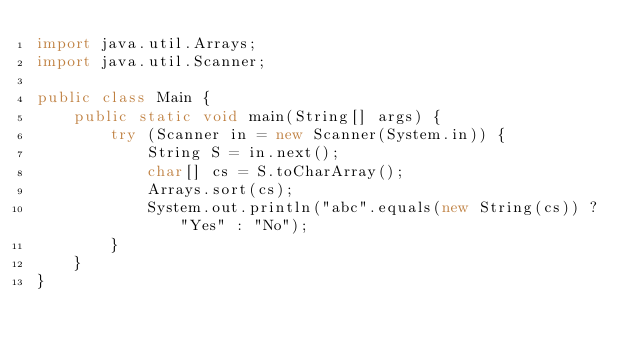<code> <loc_0><loc_0><loc_500><loc_500><_Java_>import java.util.Arrays;
import java.util.Scanner;

public class Main {
    public static void main(String[] args) {
        try (Scanner in = new Scanner(System.in)) {
            String S = in.next();
            char[] cs = S.toCharArray();
            Arrays.sort(cs);
            System.out.println("abc".equals(new String(cs)) ? "Yes" : "No");
        }
    }
}
</code> 